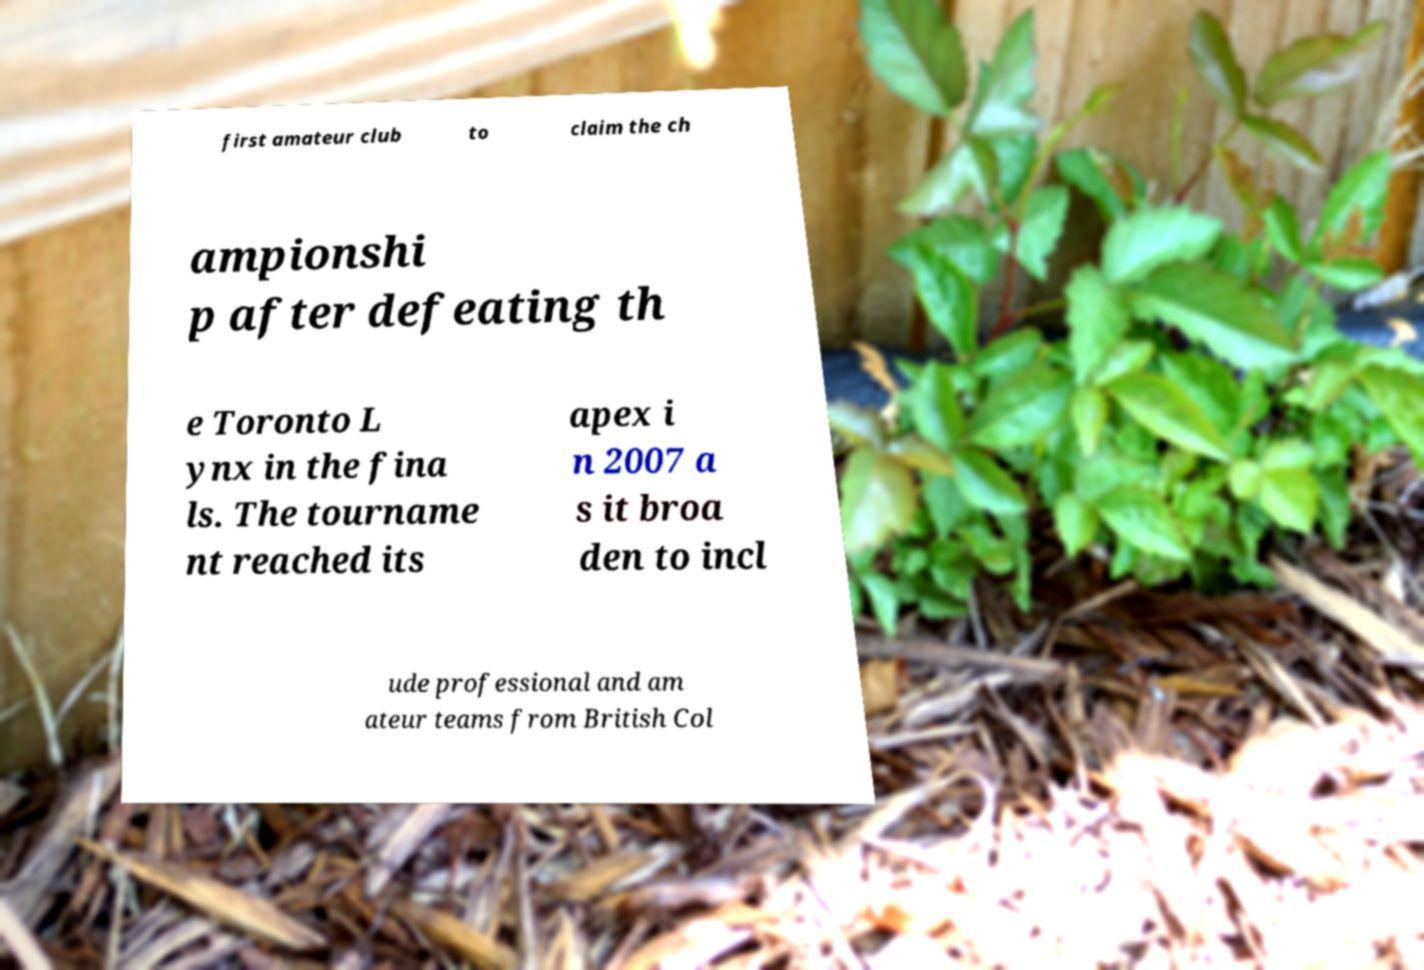For documentation purposes, I need the text within this image transcribed. Could you provide that? first amateur club to claim the ch ampionshi p after defeating th e Toronto L ynx in the fina ls. The tourname nt reached its apex i n 2007 a s it broa den to incl ude professional and am ateur teams from British Col 